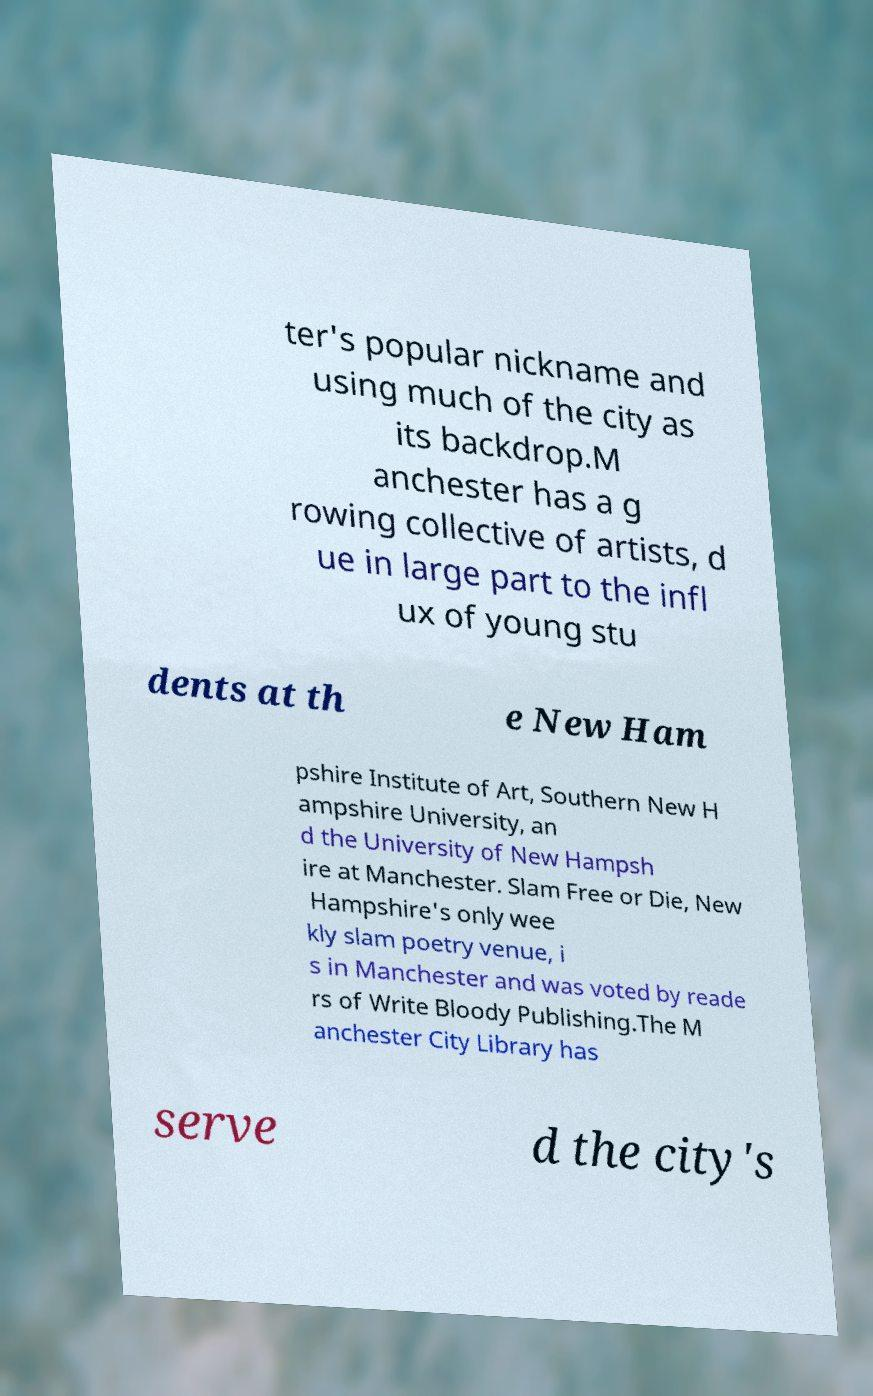What messages or text are displayed in this image? I need them in a readable, typed format. ter's popular nickname and using much of the city as its backdrop.M anchester has a g rowing collective of artists, d ue in large part to the infl ux of young stu dents at th e New Ham pshire Institute of Art, Southern New H ampshire University, an d the University of New Hampsh ire at Manchester. Slam Free or Die, New Hampshire's only wee kly slam poetry venue, i s in Manchester and was voted by reade rs of Write Bloody Publishing.The M anchester City Library has serve d the city's 